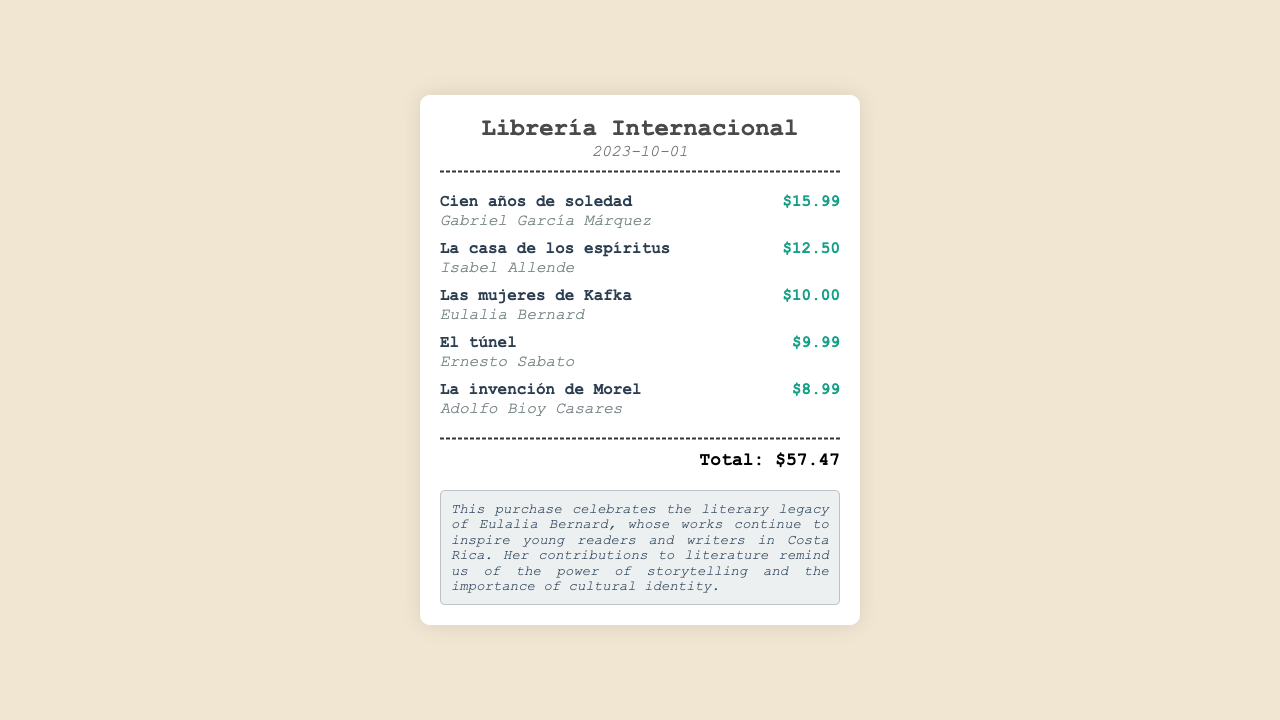What is the name of the store? The store name is located at the top of the receipt and is "Librería Internacional."
Answer: Librería Internacional What is the date of the purchase? The date on the receipt is displayed under the store name and is "2023-10-01."
Answer: 2023-10-01 Who is the author of "Cien años de soledad"? The author's name is listed next to the title on the receipt, making it identifiable as "Gabriel García Márquez."
Answer: Gabriel García Márquez What is the price of "Las mujeres de Kafka"? The price is specified alongside the title and author, which is "$10.00."
Answer: $10.00 What is the total amount spent? The total is computed from the prices of all items and is presented at the bottom of the receipt as "Total: $57.47."
Answer: $57.47 Which author's work is highlighted in the note? The note specifically mentions "Eulalia Bernard" as influential in the literary legacy.
Answer: Eulalia Bernard How many items were purchased? The count of items can be determined by the list of titles on the receipt, which shows five items.
Answer: 5 What is the title of the first book listed? The first book title is shown at the top of the items list as "Cien años de soledad."
Answer: Cien años de soledad What type of literature does the note celebrate? The note emphasizes the importance of "literary legacy," referring to contributions in literature.
Answer: Literary legacy 